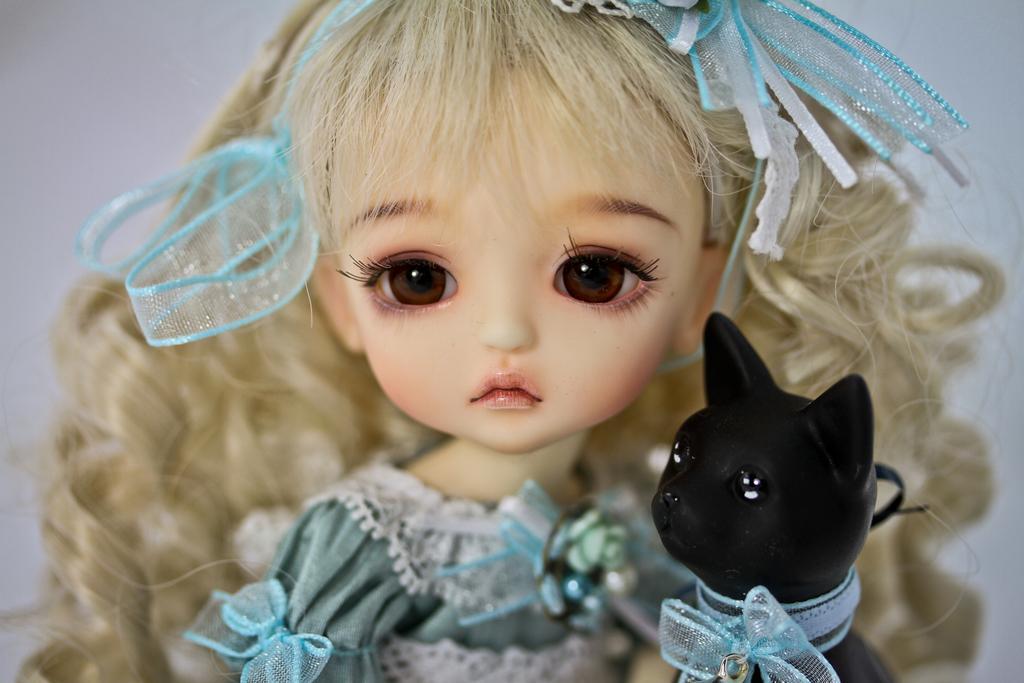Can you describe this image briefly? In the image we can see a doll wearing clothes and hair band, next to the doll there is a toy cat, black in color. The background is white and slightly blurred. 